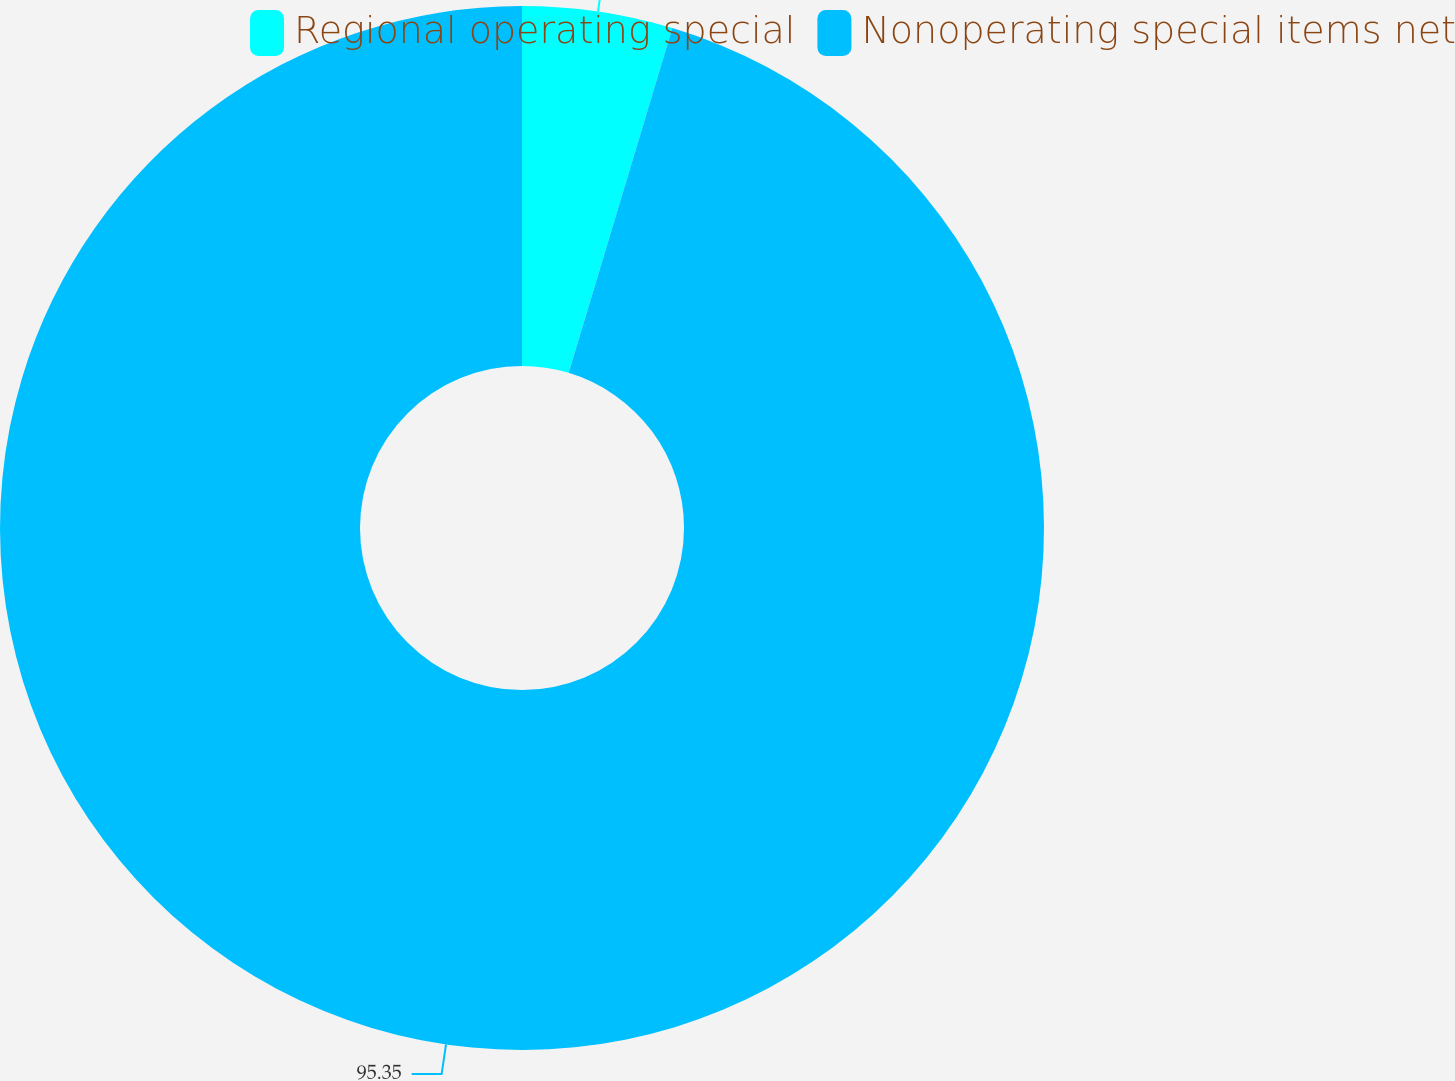<chart> <loc_0><loc_0><loc_500><loc_500><pie_chart><fcel>Regional operating special<fcel>Nonoperating special items net<nl><fcel>4.65%<fcel>95.35%<nl></chart> 